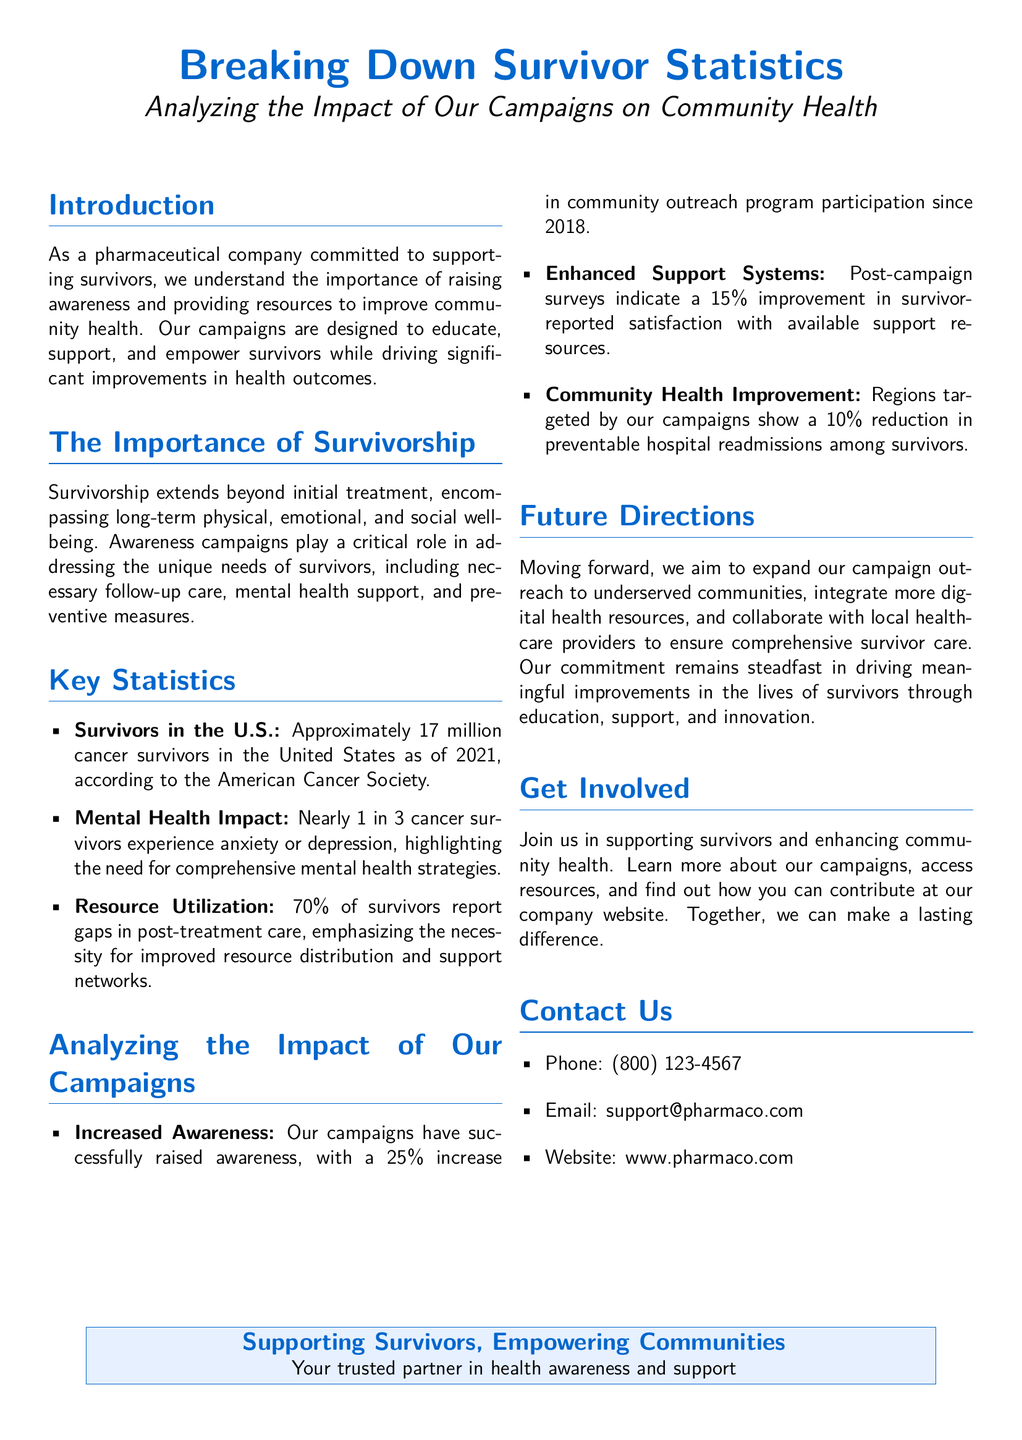What is the number of cancer survivors in the U.S. as of 2021? The document states that there are approximately 17 million cancer survivors in the United States as of 2021.
Answer: 17 million What percentage of cancer survivors experience anxiety or depression? The document mentions that nearly 1 in 3 cancer survivors experience anxiety or depression, which implies about 33%.
Answer: 1 in 3 What is the improvement in survivor-reported satisfaction with available support resources? According to the document, there is a 15% improvement in survivor-reported satisfaction after the campaigns.
Answer: 15% What percentage of survivors report gaps in post-treatment care? The document states that 70% of survivors report gaps in post-treatment care.
Answer: 70% What reduction in preventable hospital readmissions is observed in regions targeted by the campaigns? The document indicates a 10% reduction in preventable hospital readmissions among survivors in targeted regions.
Answer: 10% What has been the increase in community outreach program participation since 2018? The document reports a 25% increase in community outreach program participation since 2018.
Answer: 25% What is the main goal of expanding campaign outreach? The document emphasizes the aim to expand outreach to underserved communities.
Answer: Underserved communities What type of resources does the company intend to integrate more of? The document states the intention to integrate more digital health resources in future campaigns.
Answer: Digital health resources What is the contact phone number listed in the document? The document provides a contact phone number for inquiries as (800) 123-4567.
Answer: (800) 123-4567 What phrase summarizes the company's mission in supporting survivors? The document concludes with the phrase "Supporting Survivors, Empowering Communities."
Answer: Supporting Survivors, Empowering Communities 